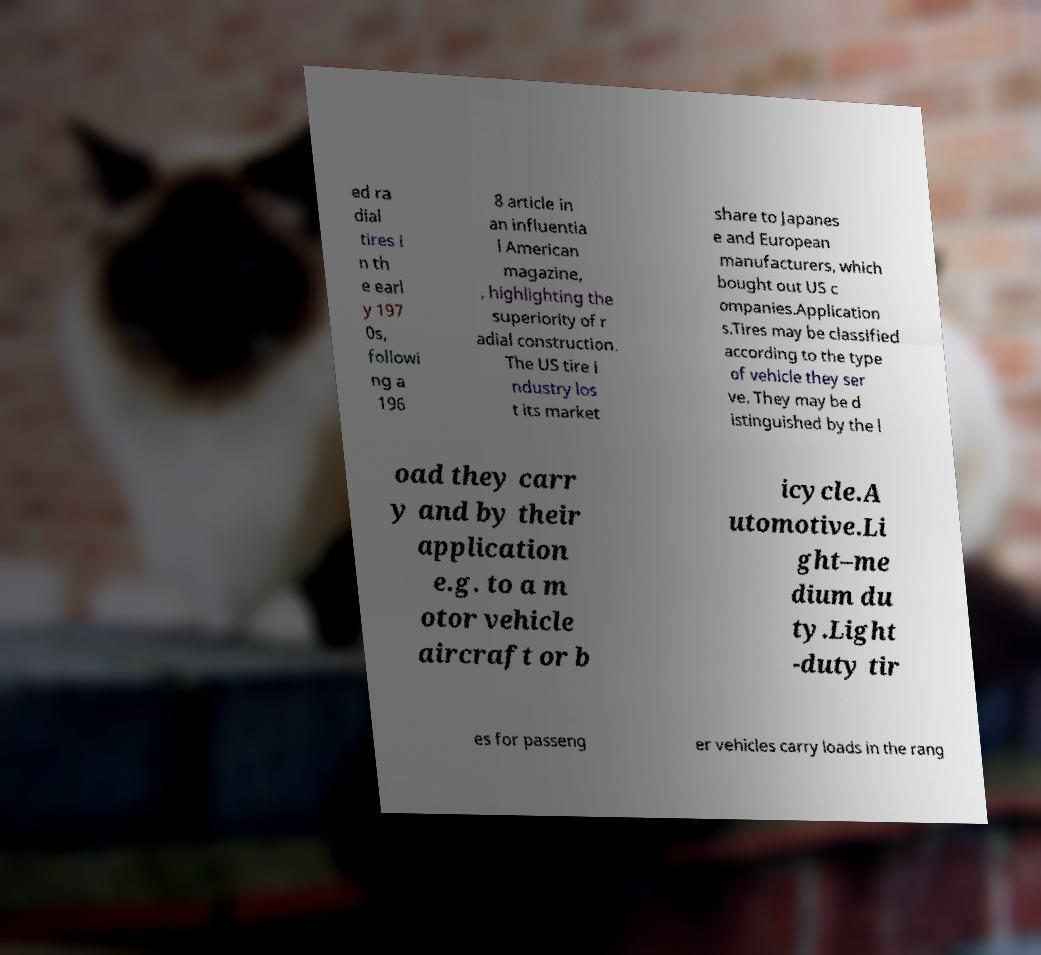Please identify and transcribe the text found in this image. ed ra dial tires i n th e earl y 197 0s, followi ng a 196 8 article in an influentia l American magazine, , highlighting the superiority of r adial construction. The US tire i ndustry los t its market share to Japanes e and European manufacturers, which bought out US c ompanies.Application s.Tires may be classified according to the type of vehicle they ser ve. They may be d istinguished by the l oad they carr y and by their application e.g. to a m otor vehicle aircraft or b icycle.A utomotive.Li ght–me dium du ty.Light -duty tir es for passeng er vehicles carry loads in the rang 